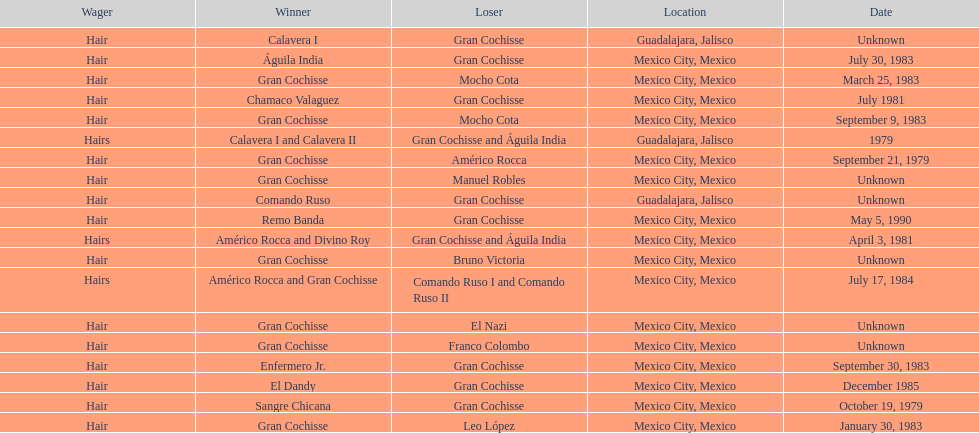How many times has gran cochisse been a winner? 9. 